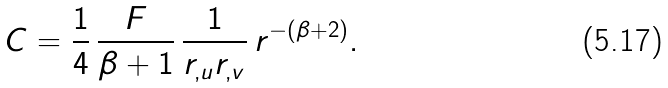<formula> <loc_0><loc_0><loc_500><loc_500>C = \frac { 1 } { 4 } \, \frac { F } { \beta + 1 } \, \frac { 1 } { r _ { , u } r _ { , v } } \, r ^ { - ( \beta + 2 ) } .</formula> 